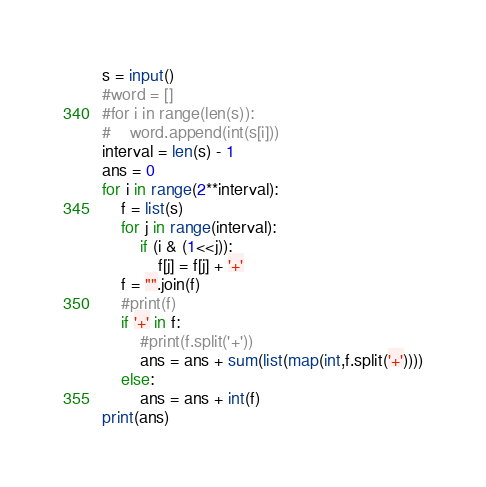Convert code to text. <code><loc_0><loc_0><loc_500><loc_500><_Python_>s = input()
#word = []
#for i in range(len(s)):
#    word.append(int(s[i]))
interval = len(s) - 1
ans = 0
for i in range(2**interval):
    f = list(s)
    for j in range(interval):
        if (i & (1<<j)):
            f[j] = f[j] + '+'
    f = "".join(f)
    #print(f)
    if '+' in f:
        #print(f.split('+'))
        ans = ans + sum(list(map(int,f.split('+'))))
    else:
        ans = ans + int(f)
print(ans)</code> 